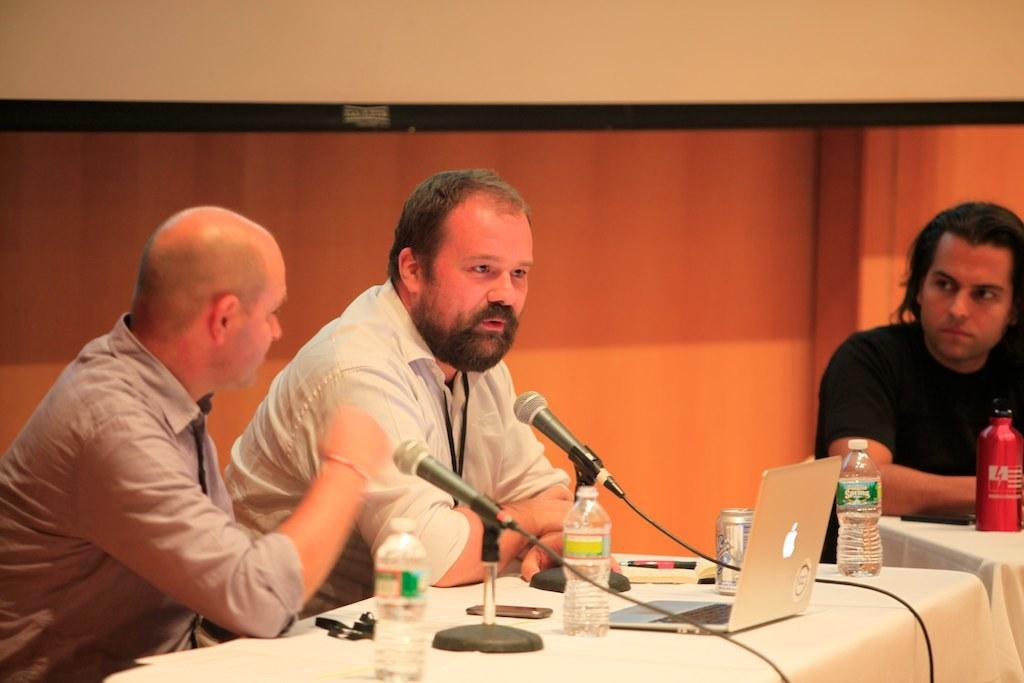How many people are sitting at the table in the image? There are two men sitting at a table in the image. What is one of the men doing at the table? One of the men is speaking with a mic in front of him. Can you describe the third person in the image? There is a man at a distance listening to them. What type of plants can be seen in the yard in the image? There is no yard or plants present in the image. 